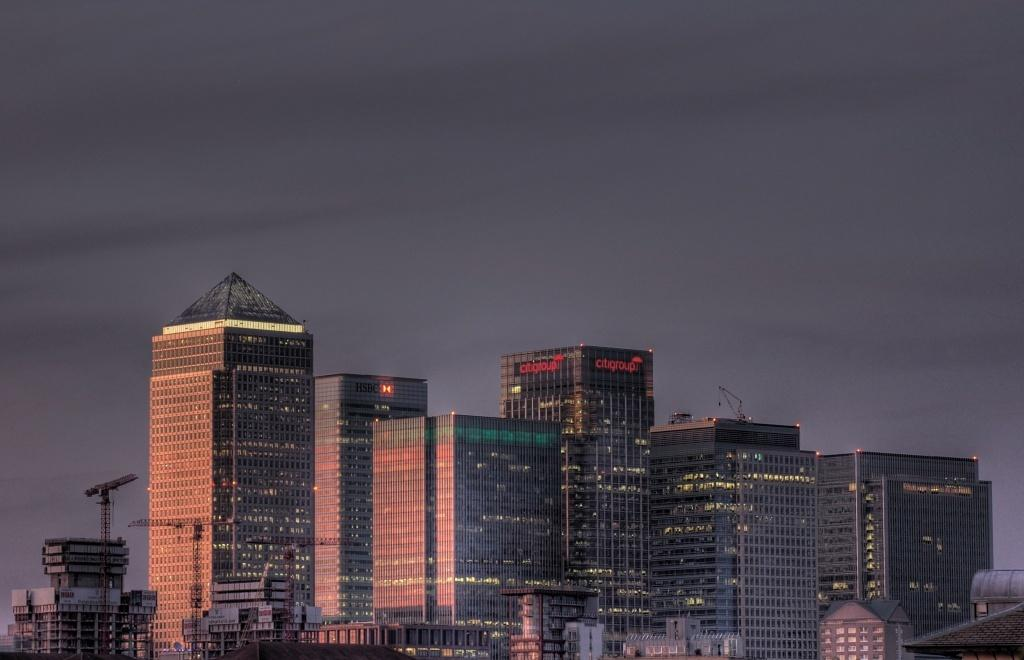What type of location is shown in the image? The image depicts a city. What structures can be seen in the city? There are buildings in the image. What can be seen in the distance in the image? The sky is visible in the background of the image. What type of discovery was made in the city in the image? There is no indication of a discovery in the image; it simply depicts a city with buildings and a visible sky. Can you tell me how many apples are on the ground in the image? There are no apples present in the image. 